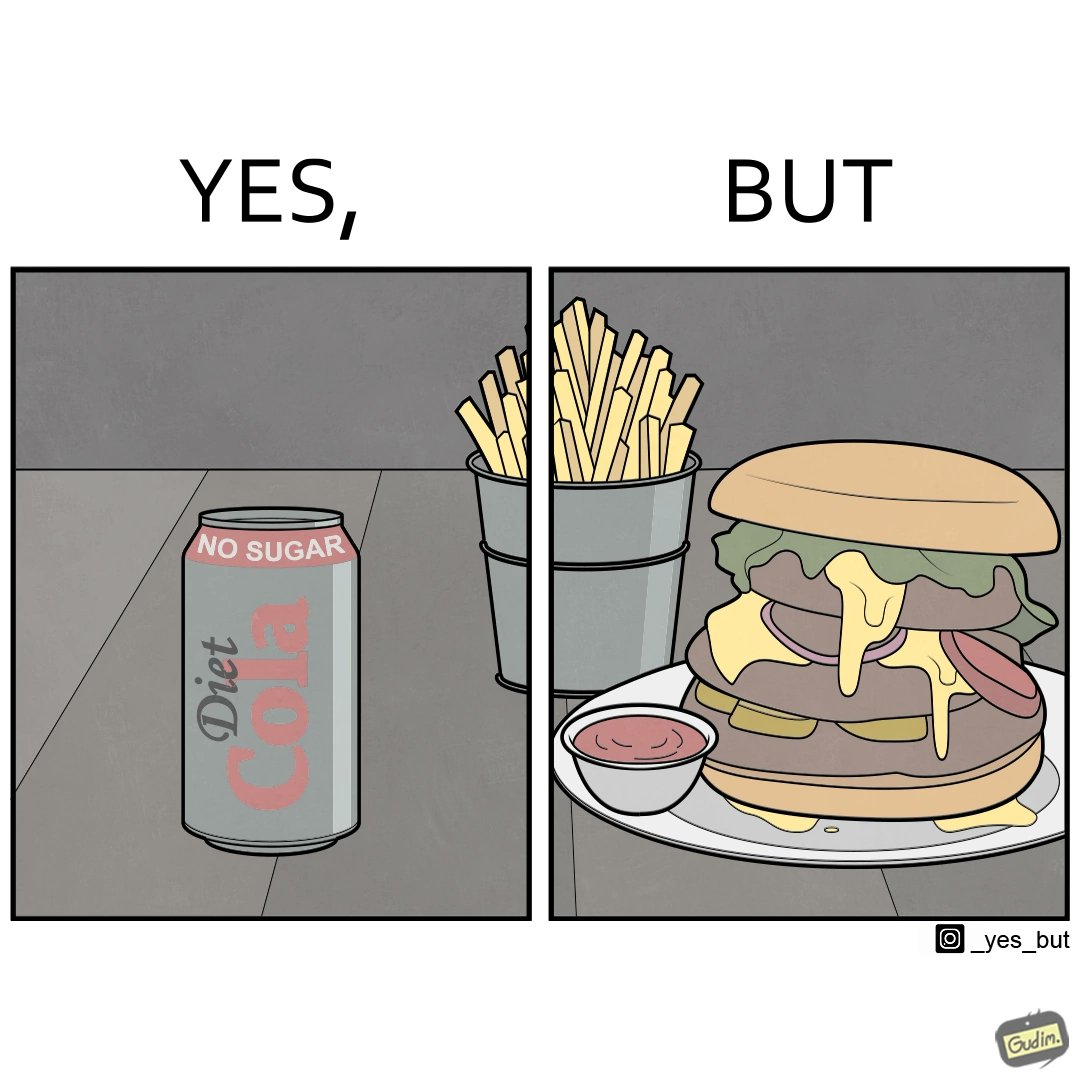Describe what you see in this image. The image is ironic, because on one hand the person is consuming diet cola suggesting low on sugar as per label meaning the person is health-conscious but on the other hand the same one is having huge size burger with french fries which suggests the person to be health-ignorant 